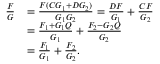<formula> <loc_0><loc_0><loc_500><loc_500>{ \begin{array} { r l } { { \frac { F } { G } } } & { = { \frac { F ( C G _ { 1 } + D G _ { 2 } ) } { G _ { 1 } G _ { 2 } } } = { \frac { D F } { G _ { 1 } } } + { \frac { C F } { G _ { 2 } } } } \\ & { = { \frac { F _ { 1 } + G _ { 1 } Q } { G _ { 1 } } } + { \frac { F _ { 2 } - G _ { 2 } Q } { G _ { 2 } } } } \\ & { = { \frac { F _ { 1 } } { G _ { 1 } } } + { \frac { F _ { 2 } } { G _ { 2 } } } . } \end{array} }</formula> 